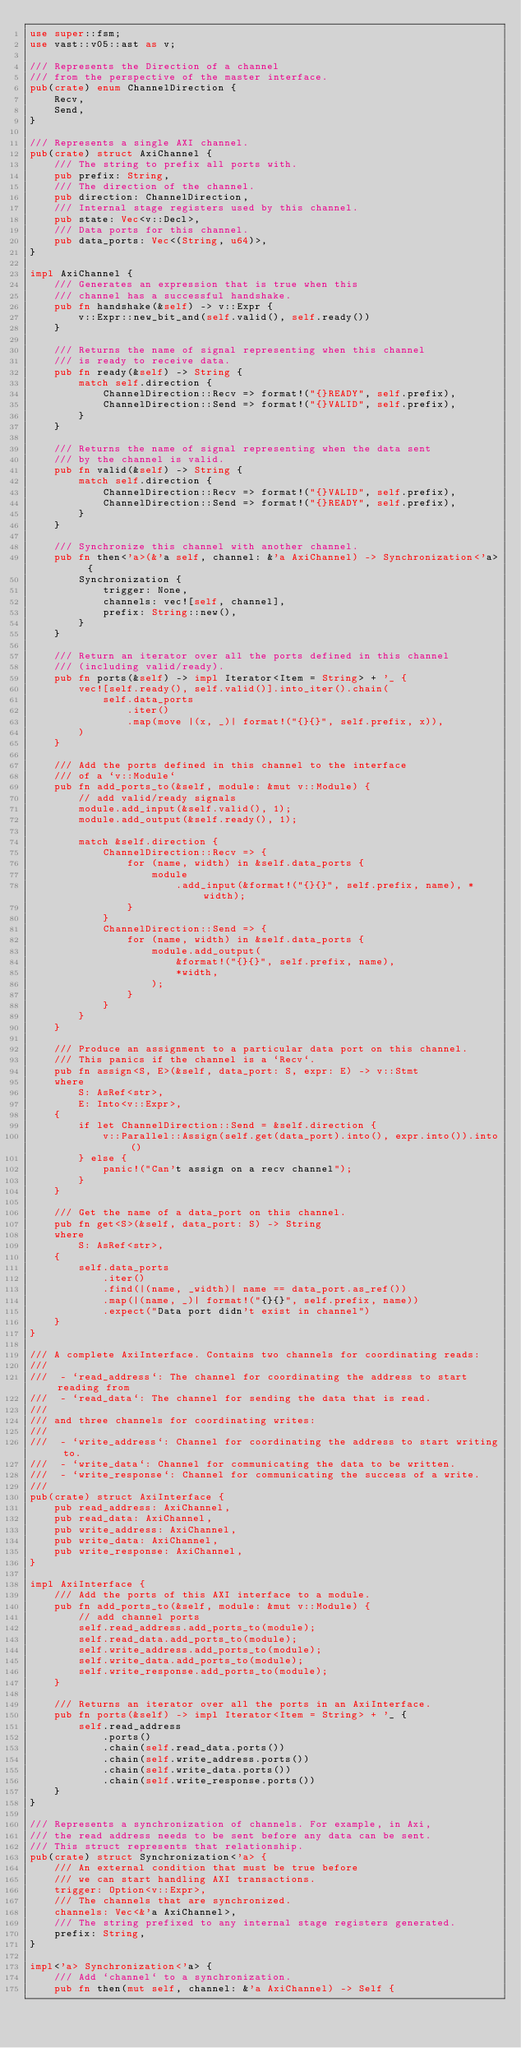<code> <loc_0><loc_0><loc_500><loc_500><_Rust_>use super::fsm;
use vast::v05::ast as v;

/// Represents the Direction of a channel
/// from the perspective of the master interface.
pub(crate) enum ChannelDirection {
    Recv,
    Send,
}

/// Represents a single AXI channel.
pub(crate) struct AxiChannel {
    /// The string to prefix all ports with.
    pub prefix: String,
    /// The direction of the channel.
    pub direction: ChannelDirection,
    /// Internal stage registers used by this channel.
    pub state: Vec<v::Decl>,
    /// Data ports for this channel.
    pub data_ports: Vec<(String, u64)>,
}

impl AxiChannel {
    /// Generates an expression that is true when this
    /// channel has a successful handshake.
    pub fn handshake(&self) -> v::Expr {
        v::Expr::new_bit_and(self.valid(), self.ready())
    }

    /// Returns the name of signal representing when this channel
    /// is ready to receive data.
    pub fn ready(&self) -> String {
        match self.direction {
            ChannelDirection::Recv => format!("{}READY", self.prefix),
            ChannelDirection::Send => format!("{}VALID", self.prefix),
        }
    }

    /// Returns the name of signal representing when the data sent
    /// by the channel is valid.
    pub fn valid(&self) -> String {
        match self.direction {
            ChannelDirection::Recv => format!("{}VALID", self.prefix),
            ChannelDirection::Send => format!("{}READY", self.prefix),
        }
    }

    /// Synchronize this channel with another channel.
    pub fn then<'a>(&'a self, channel: &'a AxiChannel) -> Synchronization<'a> {
        Synchronization {
            trigger: None,
            channels: vec![self, channel],
            prefix: String::new(),
        }
    }

    /// Return an iterator over all the ports defined in this channel
    /// (including valid/ready).
    pub fn ports(&self) -> impl Iterator<Item = String> + '_ {
        vec![self.ready(), self.valid()].into_iter().chain(
            self.data_ports
                .iter()
                .map(move |(x, _)| format!("{}{}", self.prefix, x)),
        )
    }

    /// Add the ports defined in this channel to the interface
    /// of a `v::Module`
    pub fn add_ports_to(&self, module: &mut v::Module) {
        // add valid/ready signals
        module.add_input(&self.valid(), 1);
        module.add_output(&self.ready(), 1);

        match &self.direction {
            ChannelDirection::Recv => {
                for (name, width) in &self.data_ports {
                    module
                        .add_input(&format!("{}{}", self.prefix, name), *width);
                }
            }
            ChannelDirection::Send => {
                for (name, width) in &self.data_ports {
                    module.add_output(
                        &format!("{}{}", self.prefix, name),
                        *width,
                    );
                }
            }
        }
    }

    /// Produce an assignment to a particular data port on this channel.
    /// This panics if the channel is a `Recv`.
    pub fn assign<S, E>(&self, data_port: S, expr: E) -> v::Stmt
    where
        S: AsRef<str>,
        E: Into<v::Expr>,
    {
        if let ChannelDirection::Send = &self.direction {
            v::Parallel::Assign(self.get(data_port).into(), expr.into()).into()
        } else {
            panic!("Can't assign on a recv channel");
        }
    }

    /// Get the name of a data_port on this channel.
    pub fn get<S>(&self, data_port: S) -> String
    where
        S: AsRef<str>,
    {
        self.data_ports
            .iter()
            .find(|(name, _width)| name == data_port.as_ref())
            .map(|(name, _)| format!("{}{}", self.prefix, name))
            .expect("Data port didn't exist in channel")
    }
}

/// A complete AxiInterface. Contains two channels for coordinating reads:
///
///  - `read_address`: The channel for coordinating the address to start reading from
///  - `read_data`: The channel for sending the data that is read.
///
/// and three channels for coordinating writes:
///
///  - `write_address`: Channel for coordinating the address to start writing to.
///  - `write_data`: Channel for communicating the data to be written.
///  - `write_response`: Channel for communicating the success of a write.
///
pub(crate) struct AxiInterface {
    pub read_address: AxiChannel,
    pub read_data: AxiChannel,
    pub write_address: AxiChannel,
    pub write_data: AxiChannel,
    pub write_response: AxiChannel,
}

impl AxiInterface {
    /// Add the ports of this AXI interface to a module.
    pub fn add_ports_to(&self, module: &mut v::Module) {
        // add channel ports
        self.read_address.add_ports_to(module);
        self.read_data.add_ports_to(module);
        self.write_address.add_ports_to(module);
        self.write_data.add_ports_to(module);
        self.write_response.add_ports_to(module);
    }

    /// Returns an iterator over all the ports in an AxiInterface.
    pub fn ports(&self) -> impl Iterator<Item = String> + '_ {
        self.read_address
            .ports()
            .chain(self.read_data.ports())
            .chain(self.write_address.ports())
            .chain(self.write_data.ports())
            .chain(self.write_response.ports())
    }
}

/// Represents a synchronization of channels. For example, in Axi,
/// the read address needs to be sent before any data can be sent.
/// This struct represents that relationship.
pub(crate) struct Synchronization<'a> {
    /// An external condition that must be true before
    /// we can start handling AXI transactions.
    trigger: Option<v::Expr>,
    /// The channels that are synchronized.
    channels: Vec<&'a AxiChannel>,
    /// The string prefixed to any internal stage registers generated.
    prefix: String,
}

impl<'a> Synchronization<'a> {
    /// Add `channel` to a synchronization.
    pub fn then(mut self, channel: &'a AxiChannel) -> Self {</code> 